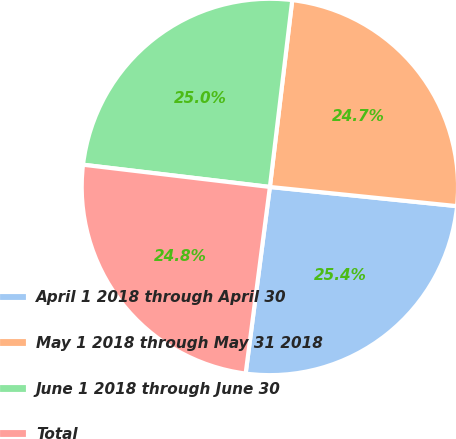Convert chart to OTSL. <chart><loc_0><loc_0><loc_500><loc_500><pie_chart><fcel>April 1 2018 through April 30<fcel>May 1 2018 through May 31 2018<fcel>June 1 2018 through June 30<fcel>Total<nl><fcel>25.43%<fcel>24.73%<fcel>25.01%<fcel>24.83%<nl></chart> 